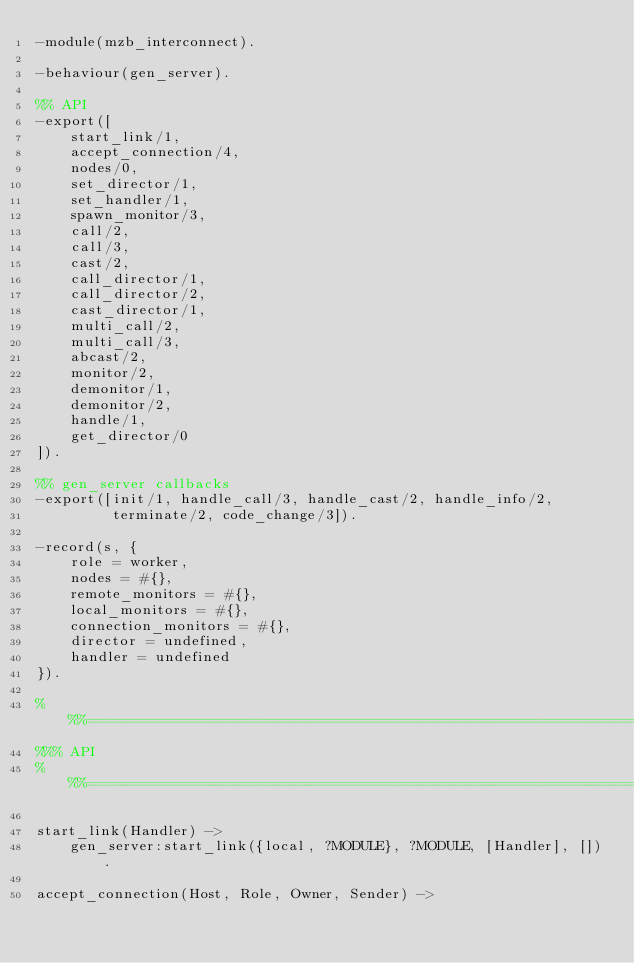<code> <loc_0><loc_0><loc_500><loc_500><_Erlang_>-module(mzb_interconnect).

-behaviour(gen_server).

%% API
-export([
    start_link/1,
    accept_connection/4,
    nodes/0,
    set_director/1,
    set_handler/1,
    spawn_monitor/3,
    call/2,
    call/3,
    cast/2,
    call_director/1,
    call_director/2,
    cast_director/1,
    multi_call/2,
    multi_call/3,
    abcast/2,
    monitor/2,
    demonitor/1,
    demonitor/2,
    handle/1,
    get_director/0
]).

%% gen_server callbacks
-export([init/1, handle_call/3, handle_cast/2, handle_info/2,
         terminate/2, code_change/3]).

-record(s, {
    role = worker,
    nodes = #{},
    remote_monitors = #{},
    local_monitors = #{},
    connection_monitors = #{},
    director = undefined,
    handler = undefined
}).

%%%===================================================================
%%% API
%%%===================================================================

start_link(Handler) ->
    gen_server:start_link({local, ?MODULE}, ?MODULE, [Handler], []).

accept_connection(Host, Role, Owner, Sender) -></code> 